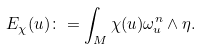<formula> <loc_0><loc_0><loc_500><loc_500>E _ { \chi } ( u ) \colon = \int _ { M } \chi ( u ) \omega ^ { n } _ { u } \wedge \eta .</formula> 